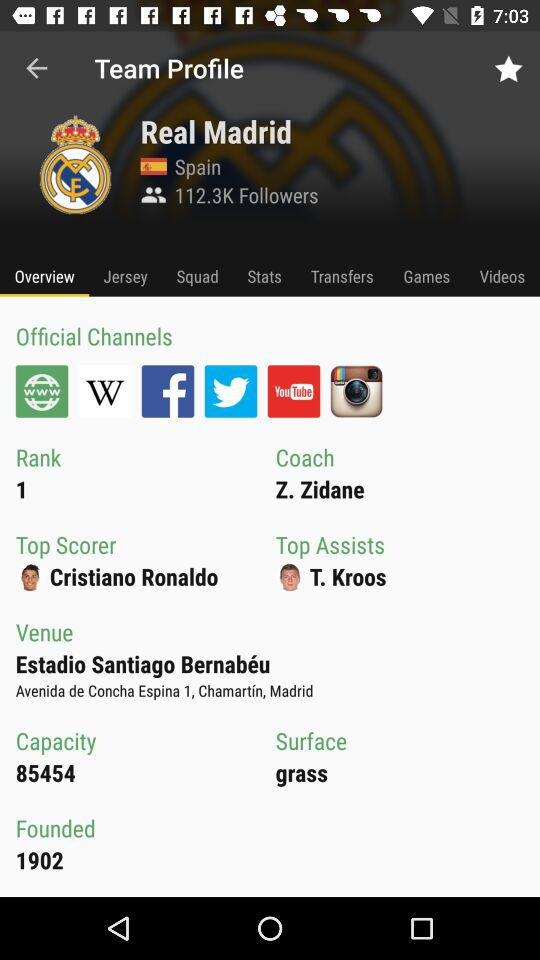What is the ranking of the team? The ranking of the team is 1. 